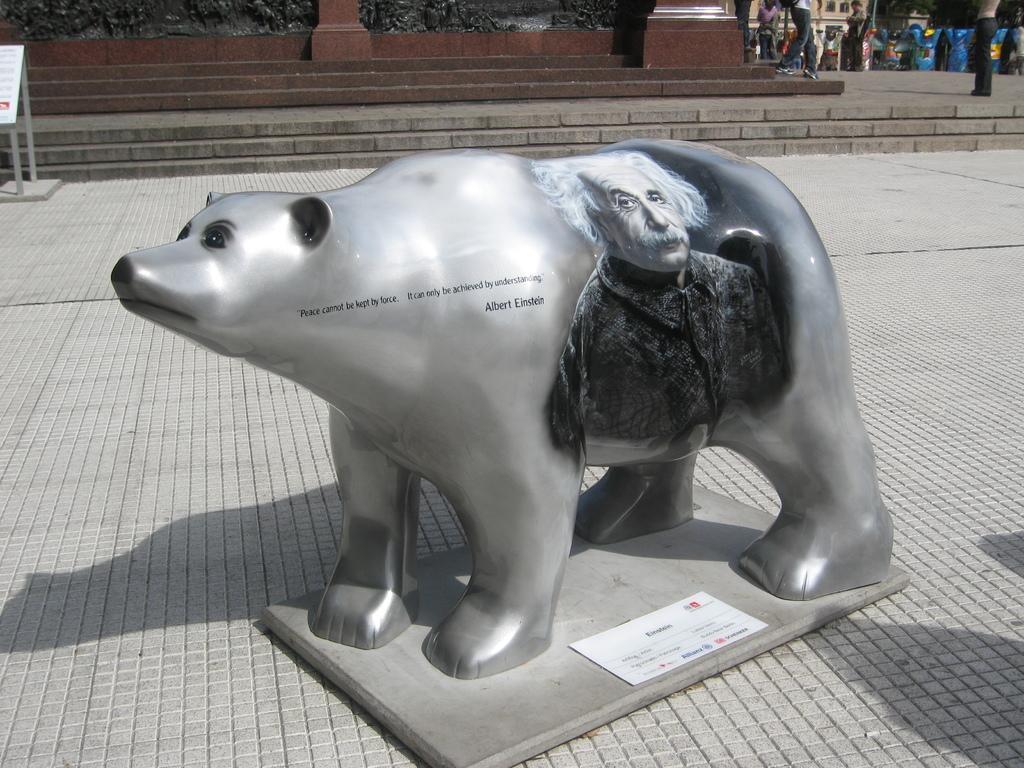In one or two sentences, can you explain what this image depicts? In this image we can see a sculpture. In the background there are people and we can see buildings. On the left there is a board. 